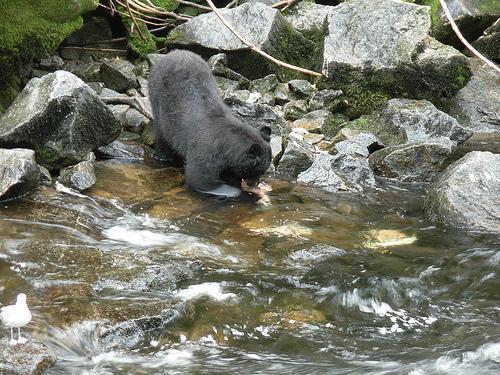How many bears are there?
Give a very brief answer. 1. 